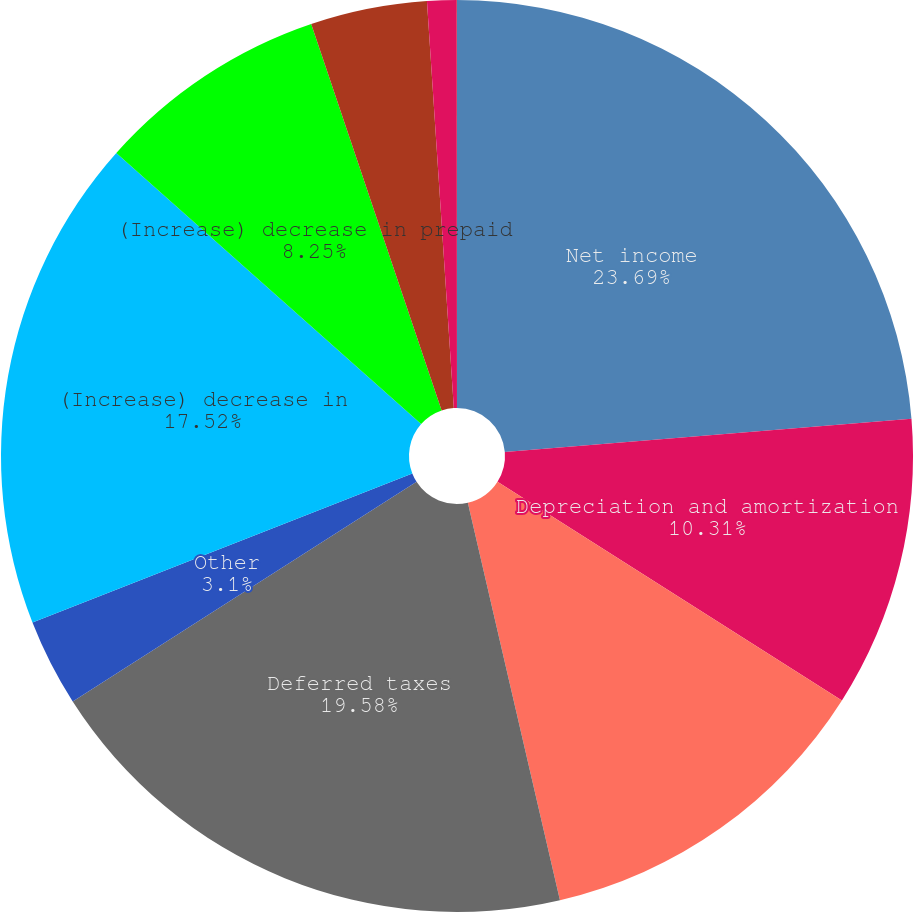Convert chart to OTSL. <chart><loc_0><loc_0><loc_500><loc_500><pie_chart><fcel>Net income<fcel>Depreciation and amortization<fcel>Stock-based compensation<fcel>Deferred taxes<fcel>Other<fcel>(Increase) decrease in<fcel>(Increase) decrease in prepaid<fcel>Increase in accrued employee<fcel>(Decrease) increase in<fcel>Increase (decrease) in<nl><fcel>23.7%<fcel>10.31%<fcel>12.37%<fcel>19.58%<fcel>3.1%<fcel>17.52%<fcel>8.25%<fcel>4.13%<fcel>1.04%<fcel>0.01%<nl></chart> 